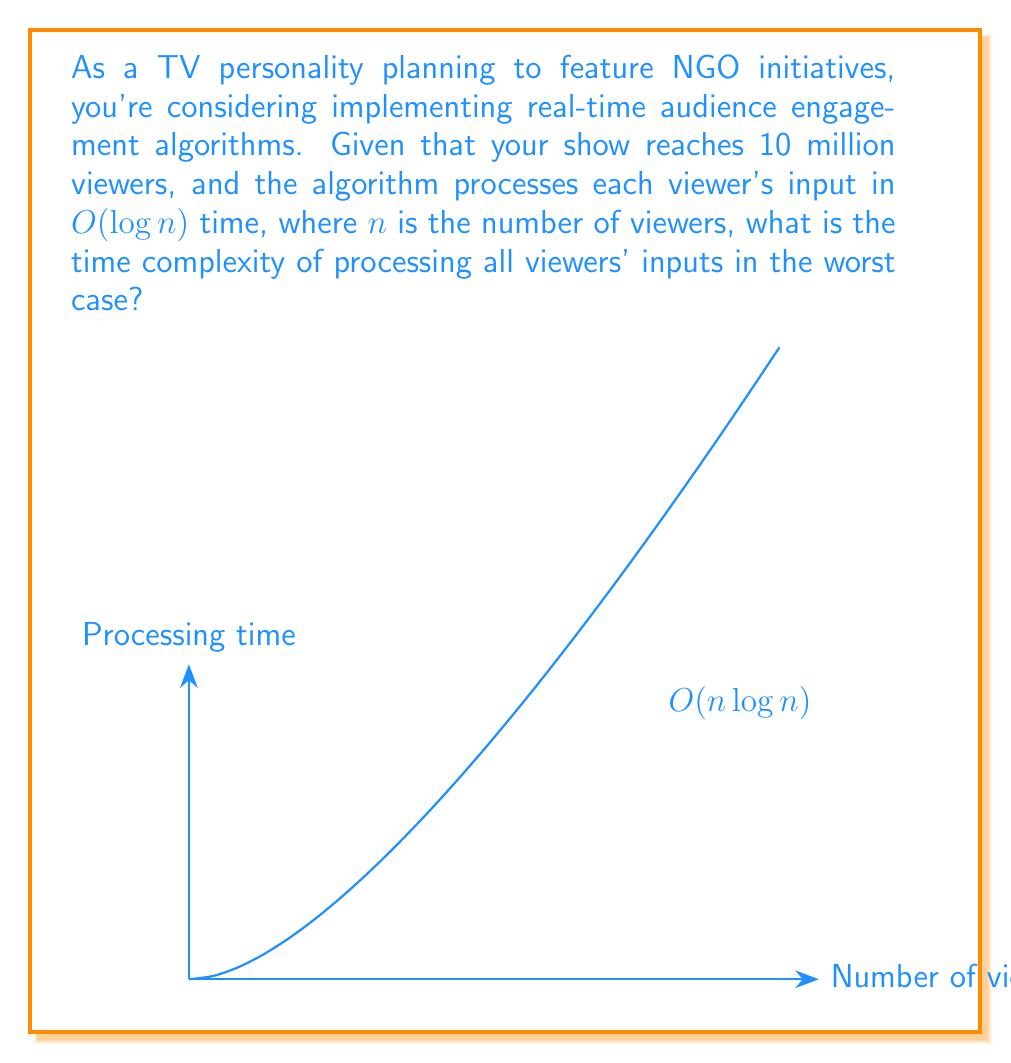Can you solve this math problem? To solve this problem, let's break it down step-by-step:

1) First, we need to understand what $O(log n)$ means. It's the time complexity for processing a single viewer's input, where $n$ is the total number of viewers.

2) We have 10 million viewers, so $n = 10,000,000$.

3) For each viewer, the algorithm takes $O(log n)$ time.

4) To process all viewers' inputs, we need to repeat this $O(log n)$ operation $n$ times.

5) When we repeat an operation $n$ times, and each operation takes $O(log n)$ time, the total time complexity becomes:

   $$O(n \cdot log n)$$

6) This is because we're essentially multiplying the number of operations $(n)$ by the time each operation takes $(log n)$.

7) Therefore, the worst-case time complexity for processing all viewers' inputs is $O(n log n)$.

8) It's worth noting that this is a common time complexity in algorithms, often seen in efficient sorting algorithms like Merge Sort and Heap Sort.
Answer: $O(n log n)$ 